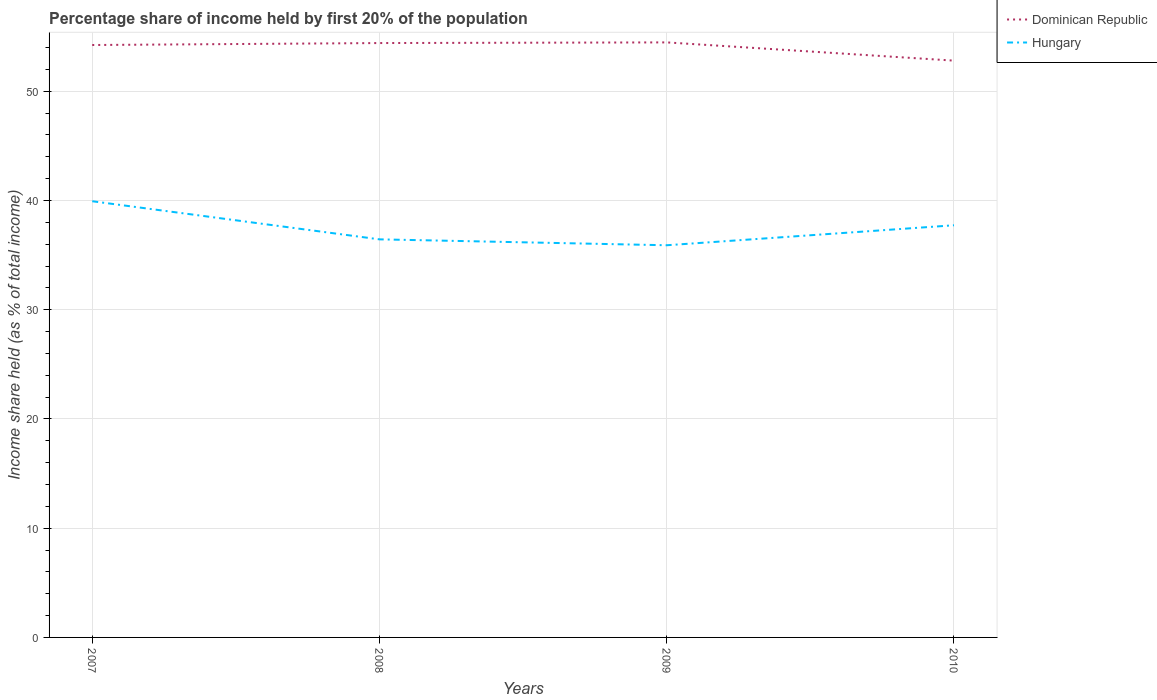Does the line corresponding to Hungary intersect with the line corresponding to Dominican Republic?
Keep it short and to the point. No. Is the number of lines equal to the number of legend labels?
Provide a succinct answer. Yes. Across all years, what is the maximum share of income held by first 20% of the population in Hungary?
Your answer should be very brief. 35.9. What is the total share of income held by first 20% of the population in Hungary in the graph?
Make the answer very short. 4.03. What is the difference between the highest and the second highest share of income held by first 20% of the population in Dominican Republic?
Provide a succinct answer. 1.67. How many lines are there?
Your answer should be very brief. 2. Does the graph contain any zero values?
Provide a succinct answer. No. Does the graph contain grids?
Your answer should be very brief. Yes. Where does the legend appear in the graph?
Offer a terse response. Top right. What is the title of the graph?
Offer a terse response. Percentage share of income held by first 20% of the population. What is the label or title of the X-axis?
Offer a very short reply. Years. What is the label or title of the Y-axis?
Your answer should be very brief. Income share held (as % of total income). What is the Income share held (as % of total income) in Dominican Republic in 2007?
Your response must be concise. 54.23. What is the Income share held (as % of total income) of Hungary in 2007?
Offer a terse response. 39.93. What is the Income share held (as % of total income) in Dominican Republic in 2008?
Provide a succinct answer. 54.41. What is the Income share held (as % of total income) in Hungary in 2008?
Your answer should be very brief. 36.44. What is the Income share held (as % of total income) in Dominican Republic in 2009?
Give a very brief answer. 54.47. What is the Income share held (as % of total income) in Hungary in 2009?
Your answer should be very brief. 35.9. What is the Income share held (as % of total income) of Dominican Republic in 2010?
Give a very brief answer. 52.8. What is the Income share held (as % of total income) in Hungary in 2010?
Provide a succinct answer. 37.73. Across all years, what is the maximum Income share held (as % of total income) of Dominican Republic?
Your response must be concise. 54.47. Across all years, what is the maximum Income share held (as % of total income) of Hungary?
Provide a short and direct response. 39.93. Across all years, what is the minimum Income share held (as % of total income) in Dominican Republic?
Ensure brevity in your answer.  52.8. Across all years, what is the minimum Income share held (as % of total income) in Hungary?
Give a very brief answer. 35.9. What is the total Income share held (as % of total income) of Dominican Republic in the graph?
Offer a very short reply. 215.91. What is the total Income share held (as % of total income) of Hungary in the graph?
Your response must be concise. 150. What is the difference between the Income share held (as % of total income) of Dominican Republic in 2007 and that in 2008?
Provide a short and direct response. -0.18. What is the difference between the Income share held (as % of total income) in Hungary in 2007 and that in 2008?
Your answer should be very brief. 3.49. What is the difference between the Income share held (as % of total income) in Dominican Republic in 2007 and that in 2009?
Make the answer very short. -0.24. What is the difference between the Income share held (as % of total income) in Hungary in 2007 and that in 2009?
Offer a very short reply. 4.03. What is the difference between the Income share held (as % of total income) of Dominican Republic in 2007 and that in 2010?
Your response must be concise. 1.43. What is the difference between the Income share held (as % of total income) in Dominican Republic in 2008 and that in 2009?
Your answer should be very brief. -0.06. What is the difference between the Income share held (as % of total income) of Hungary in 2008 and that in 2009?
Offer a very short reply. 0.54. What is the difference between the Income share held (as % of total income) of Dominican Republic in 2008 and that in 2010?
Offer a very short reply. 1.61. What is the difference between the Income share held (as % of total income) of Hungary in 2008 and that in 2010?
Offer a terse response. -1.29. What is the difference between the Income share held (as % of total income) of Dominican Republic in 2009 and that in 2010?
Keep it short and to the point. 1.67. What is the difference between the Income share held (as % of total income) in Hungary in 2009 and that in 2010?
Your answer should be compact. -1.83. What is the difference between the Income share held (as % of total income) of Dominican Republic in 2007 and the Income share held (as % of total income) of Hungary in 2008?
Ensure brevity in your answer.  17.79. What is the difference between the Income share held (as % of total income) in Dominican Republic in 2007 and the Income share held (as % of total income) in Hungary in 2009?
Keep it short and to the point. 18.33. What is the difference between the Income share held (as % of total income) in Dominican Republic in 2008 and the Income share held (as % of total income) in Hungary in 2009?
Your response must be concise. 18.51. What is the difference between the Income share held (as % of total income) in Dominican Republic in 2008 and the Income share held (as % of total income) in Hungary in 2010?
Your response must be concise. 16.68. What is the difference between the Income share held (as % of total income) in Dominican Republic in 2009 and the Income share held (as % of total income) in Hungary in 2010?
Provide a short and direct response. 16.74. What is the average Income share held (as % of total income) in Dominican Republic per year?
Offer a very short reply. 53.98. What is the average Income share held (as % of total income) of Hungary per year?
Offer a terse response. 37.5. In the year 2007, what is the difference between the Income share held (as % of total income) in Dominican Republic and Income share held (as % of total income) in Hungary?
Offer a terse response. 14.3. In the year 2008, what is the difference between the Income share held (as % of total income) in Dominican Republic and Income share held (as % of total income) in Hungary?
Make the answer very short. 17.97. In the year 2009, what is the difference between the Income share held (as % of total income) in Dominican Republic and Income share held (as % of total income) in Hungary?
Your response must be concise. 18.57. In the year 2010, what is the difference between the Income share held (as % of total income) of Dominican Republic and Income share held (as % of total income) of Hungary?
Provide a short and direct response. 15.07. What is the ratio of the Income share held (as % of total income) in Hungary in 2007 to that in 2008?
Your answer should be compact. 1.1. What is the ratio of the Income share held (as % of total income) of Hungary in 2007 to that in 2009?
Make the answer very short. 1.11. What is the ratio of the Income share held (as % of total income) of Dominican Republic in 2007 to that in 2010?
Offer a very short reply. 1.03. What is the ratio of the Income share held (as % of total income) in Hungary in 2007 to that in 2010?
Your answer should be compact. 1.06. What is the ratio of the Income share held (as % of total income) in Dominican Republic in 2008 to that in 2009?
Provide a short and direct response. 1. What is the ratio of the Income share held (as % of total income) in Hungary in 2008 to that in 2009?
Give a very brief answer. 1.01. What is the ratio of the Income share held (as % of total income) in Dominican Republic in 2008 to that in 2010?
Your answer should be very brief. 1.03. What is the ratio of the Income share held (as % of total income) of Hungary in 2008 to that in 2010?
Give a very brief answer. 0.97. What is the ratio of the Income share held (as % of total income) in Dominican Republic in 2009 to that in 2010?
Your answer should be compact. 1.03. What is the ratio of the Income share held (as % of total income) in Hungary in 2009 to that in 2010?
Make the answer very short. 0.95. What is the difference between the highest and the second highest Income share held (as % of total income) in Dominican Republic?
Keep it short and to the point. 0.06. What is the difference between the highest and the second highest Income share held (as % of total income) of Hungary?
Your answer should be very brief. 2.2. What is the difference between the highest and the lowest Income share held (as % of total income) in Dominican Republic?
Offer a terse response. 1.67. What is the difference between the highest and the lowest Income share held (as % of total income) of Hungary?
Your response must be concise. 4.03. 